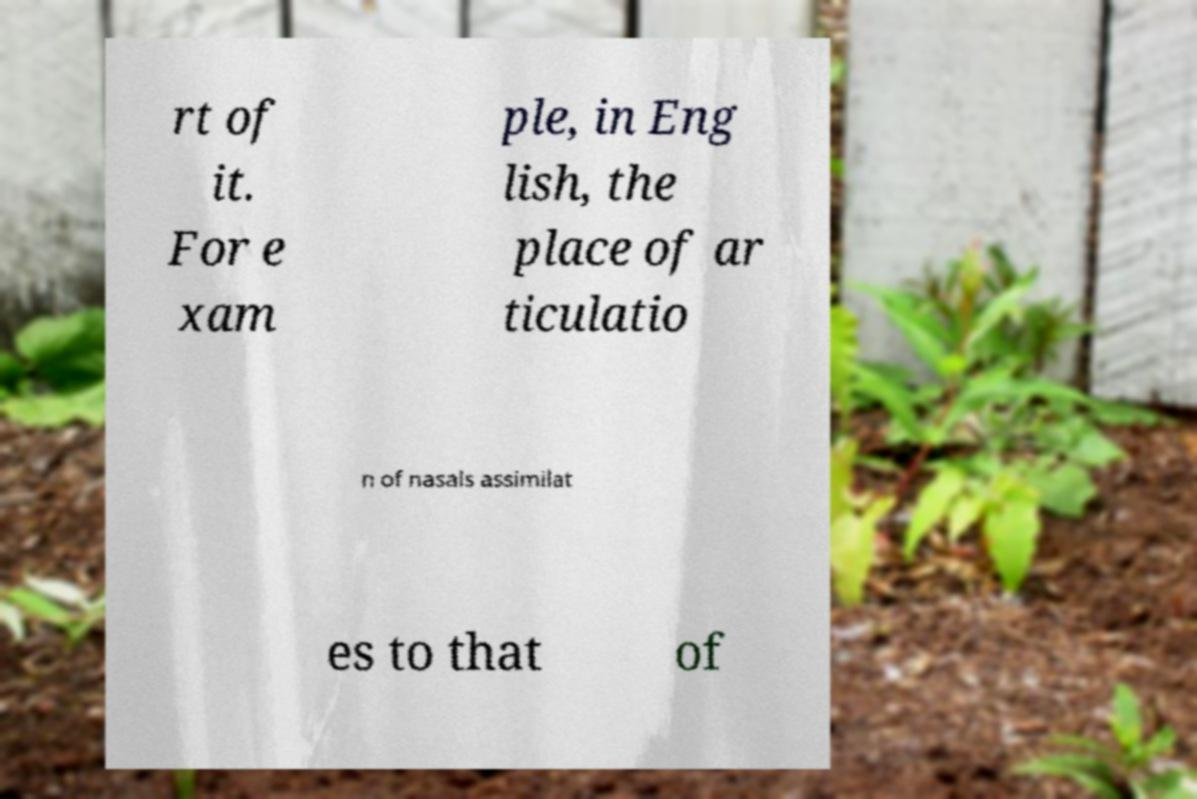Please identify and transcribe the text found in this image. rt of it. For e xam ple, in Eng lish, the place of ar ticulatio n of nasals assimilat es to that of 